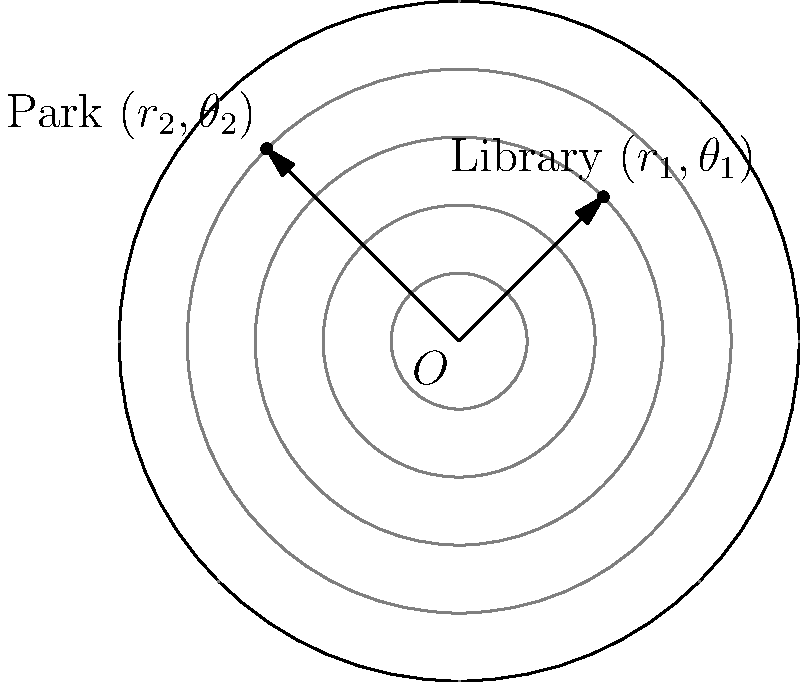Your child's favorite hobby locations, the library and the park, are represented on a polar coordinate system. The library is located at $(3, \frac{\pi}{4})$ and the park is at $(4, \frac{3\pi}{4})$. To plan efficient routes for your child's activities, you need to calculate the straight-line distance between these two locations. What is this distance? To find the distance between two points in polar coordinates, we can use the following steps:

1) Let's denote the library as point 1 $(r_1, \theta_1)$ and the park as point 2 $(r_2, \theta_2)$.

2) The formula for the distance $d$ between two points in polar coordinates is:

   $$d = \sqrt{r_1^2 + r_2^2 - 2r_1r_2\cos(\theta_2 - \theta_1)}$$

3) We have:
   $r_1 = 3$, $\theta_1 = \frac{\pi}{4}$
   $r_2 = 4$, $\theta_2 = \frac{3\pi}{4}$

4) Let's substitute these values into the formula:

   $$d = \sqrt{3^2 + 4^2 - 2(3)(4)\cos(\frac{3\pi}{4} - \frac{\pi}{4})}$$

5) Simplify inside the parentheses:
   
   $$d = \sqrt{9 + 16 - 24\cos(\frac{\pi}{2})}$$

6) We know that $\cos(\frac{\pi}{2}) = 0$, so:

   $$d = \sqrt{9 + 16 - 0} = \sqrt{25} = 5$$

Therefore, the straight-line distance between the library and the park is 5 units.
Answer: 5 units 